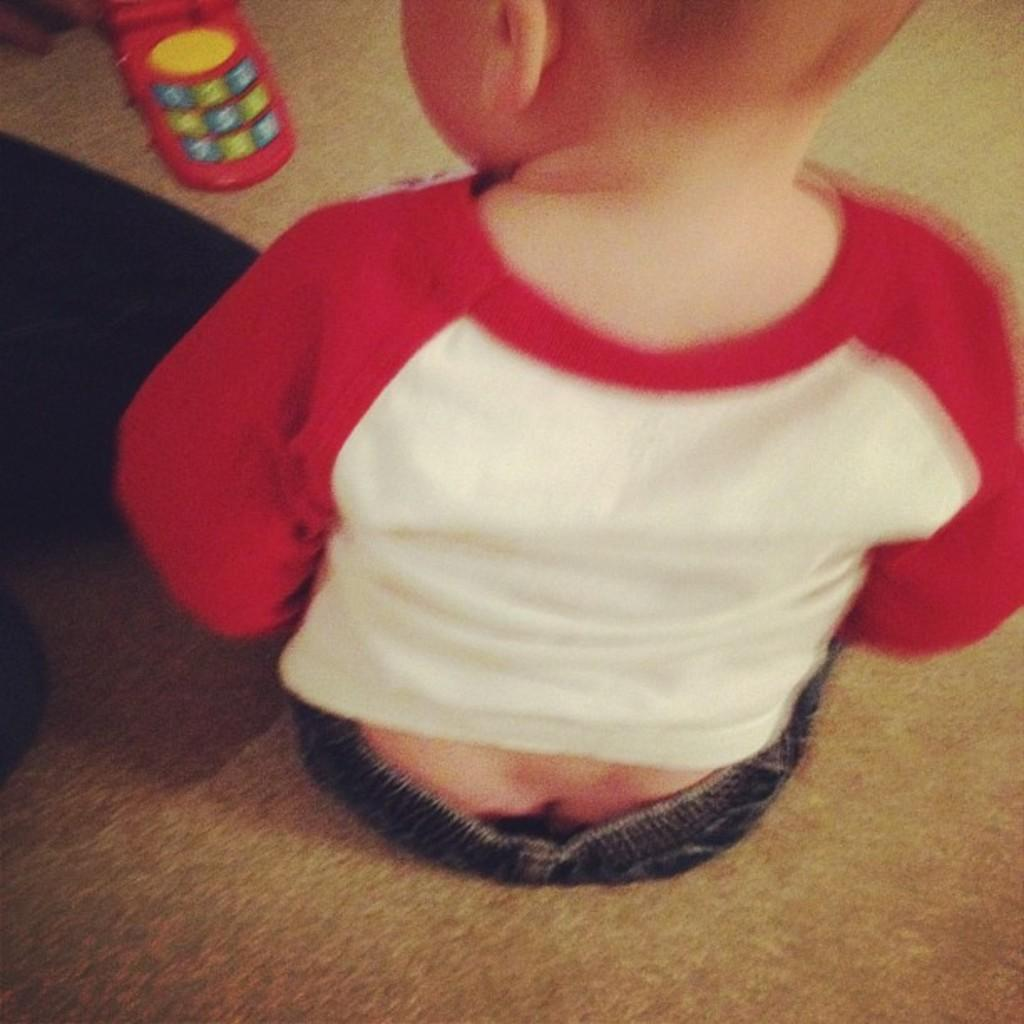What is the position of the kid in the image? The kid is sitting on the floor in the image. What object is present in the image that resembles a cell phone? There is a toy cell phone in the image. What part of the earth can be seen in the image? There is no part of the earth visible in the image; it only shows a kid sitting on the floor and a toy cell phone. 